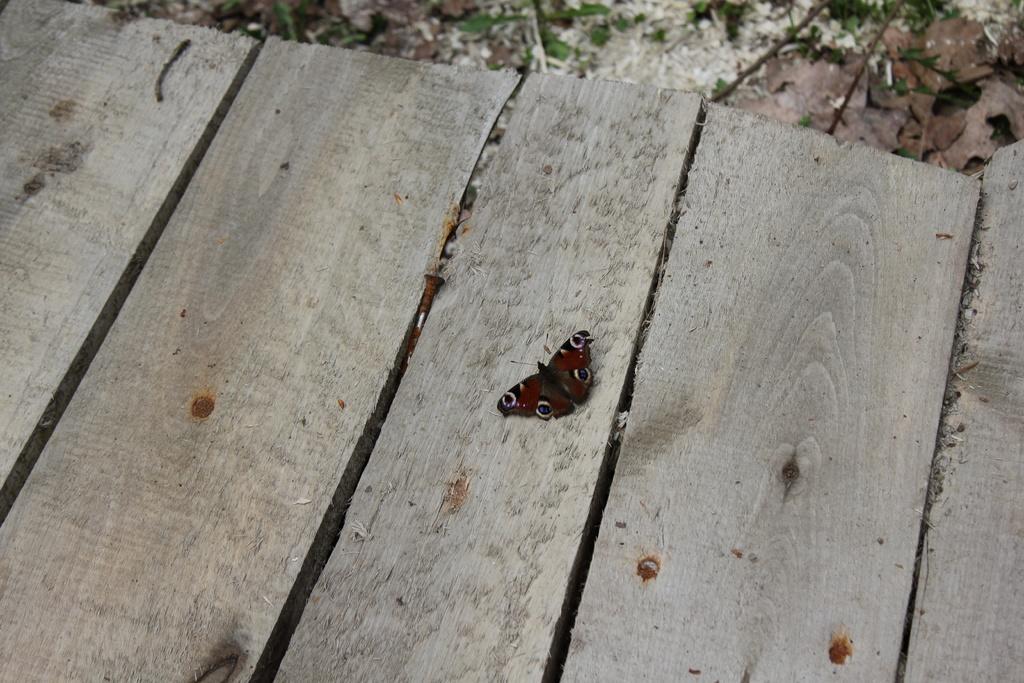Describe this image in one or two sentences. In this picture there is a butterfly on the wooden railing and there are nails on the railing. At the back there is a plant. 